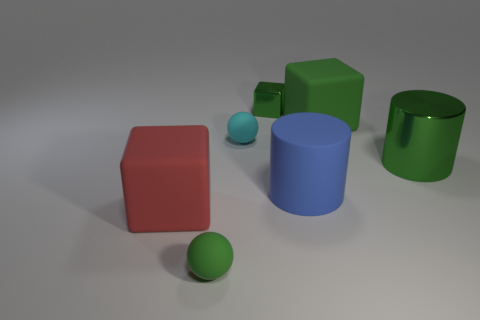What is the shape of the small metal thing that is the same color as the metal cylinder?
Your response must be concise. Cube. What number of other things are there of the same shape as the large red thing?
Ensure brevity in your answer.  2. Are there any large blue cylinders made of the same material as the big red block?
Offer a very short reply. Yes. There is a small thing that is in front of the small cyan object; is its color the same as the shiny cylinder?
Offer a terse response. Yes. What size is the cyan thing?
Provide a short and direct response. Small. There is a small rubber object behind the matte sphere in front of the big red object; are there any tiny matte spheres that are in front of it?
Provide a succinct answer. Yes. There is a large blue cylinder; how many small cyan matte balls are on the right side of it?
Provide a short and direct response. 0. What number of other large metal things have the same color as the big metal thing?
Provide a succinct answer. 0. How many things are either matte cubes left of the small green metallic object or matte things that are in front of the big green rubber block?
Offer a terse response. 4. Are there more red spheres than big green metal cylinders?
Your answer should be very brief. No. 